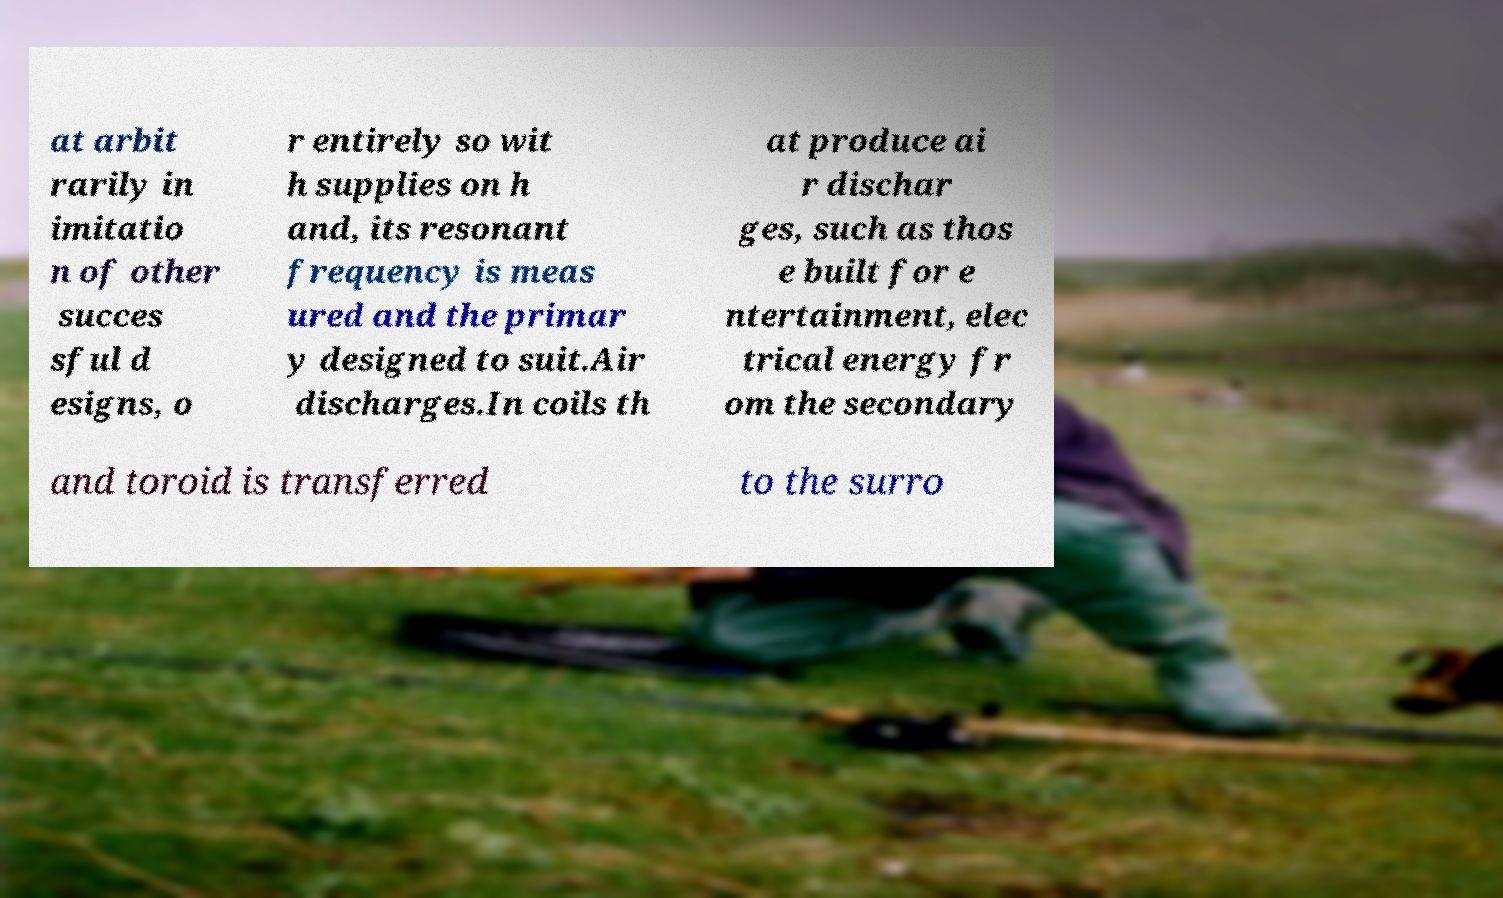For documentation purposes, I need the text within this image transcribed. Could you provide that? at arbit rarily in imitatio n of other succes sful d esigns, o r entirely so wit h supplies on h and, its resonant frequency is meas ured and the primar y designed to suit.Air discharges.In coils th at produce ai r dischar ges, such as thos e built for e ntertainment, elec trical energy fr om the secondary and toroid is transferred to the surro 